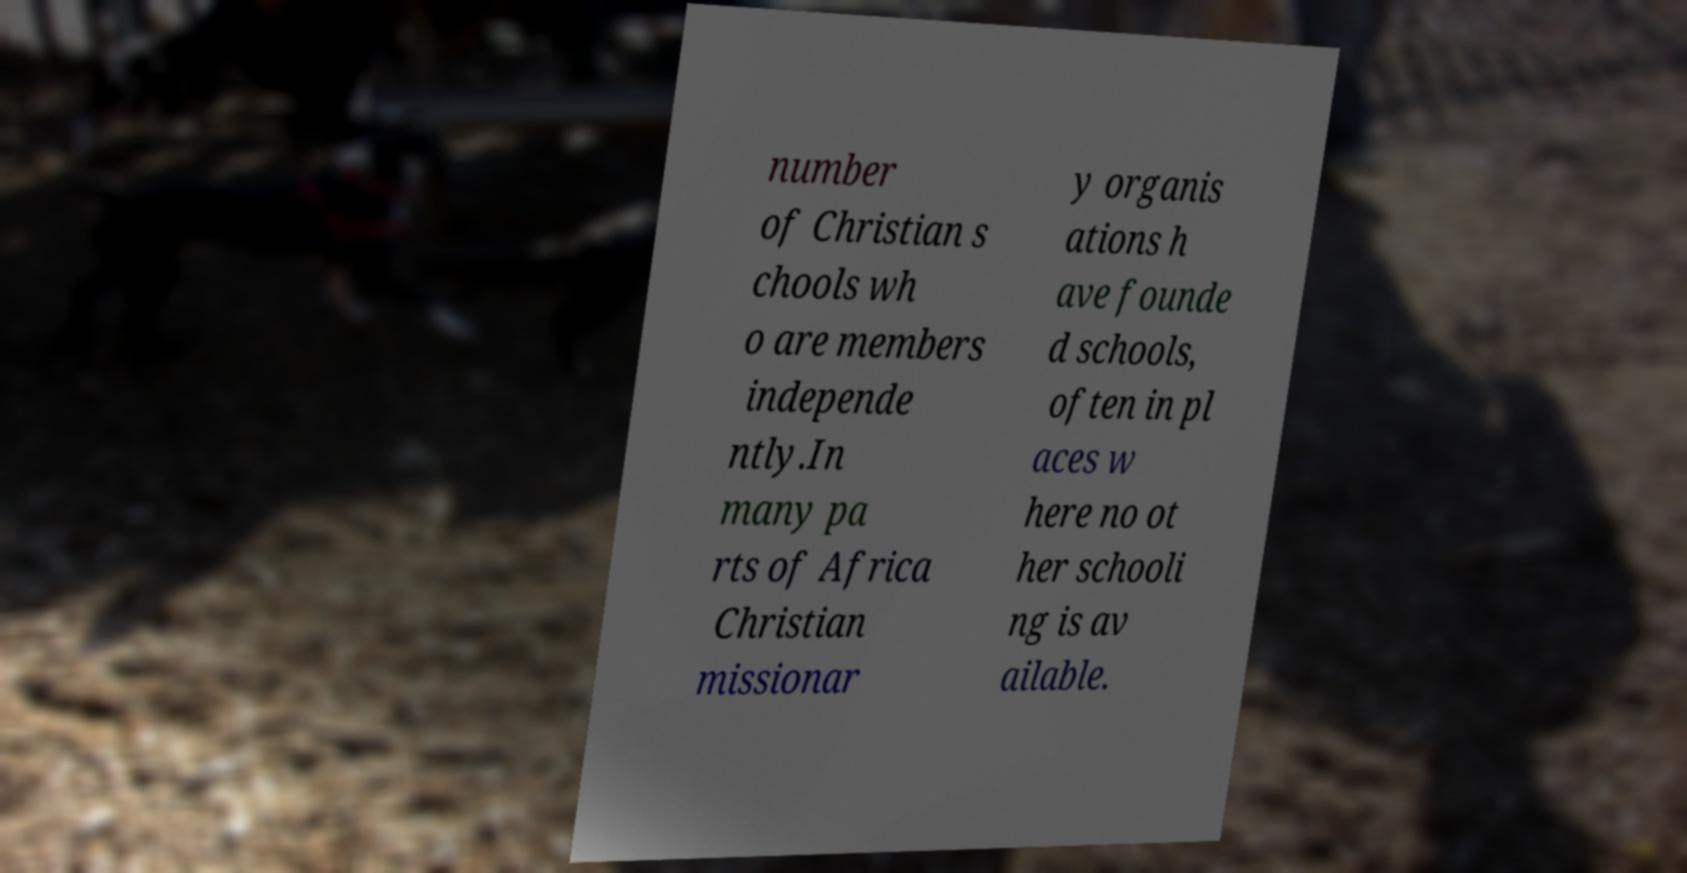Could you extract and type out the text from this image? number of Christian s chools wh o are members independe ntly.In many pa rts of Africa Christian missionar y organis ations h ave founde d schools, often in pl aces w here no ot her schooli ng is av ailable. 